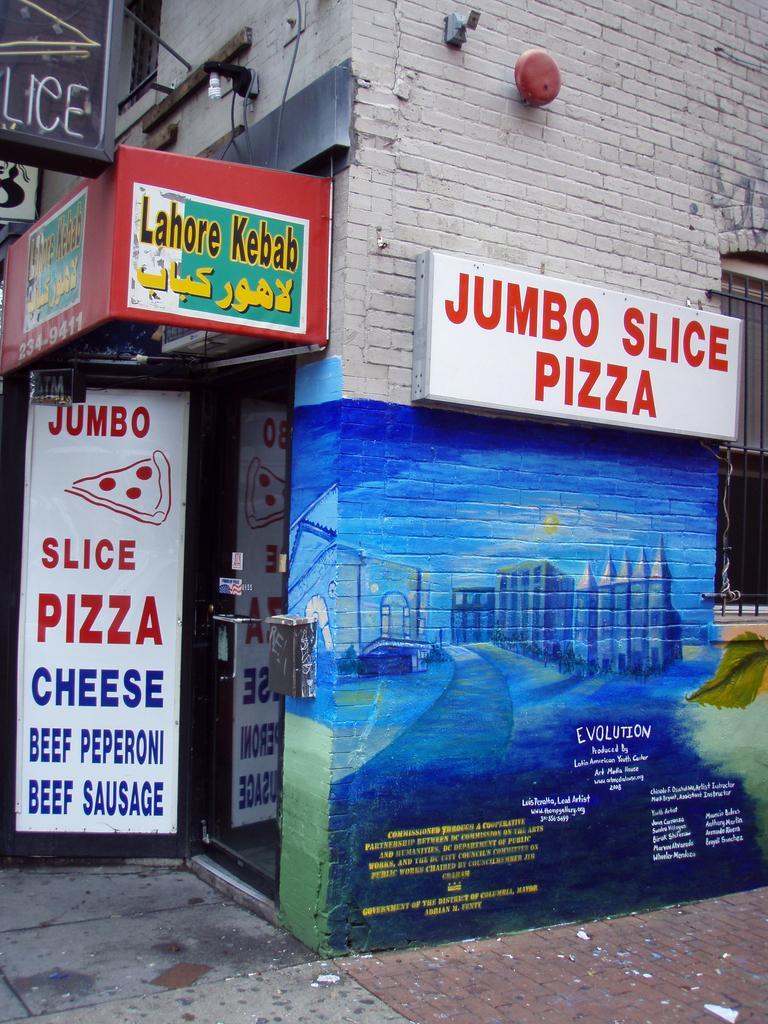In one or two sentences, can you explain what this image depicts? In this image we can see group of sign boards with text on them placed on a building along with a light and a bell. In the background we can see a window. 